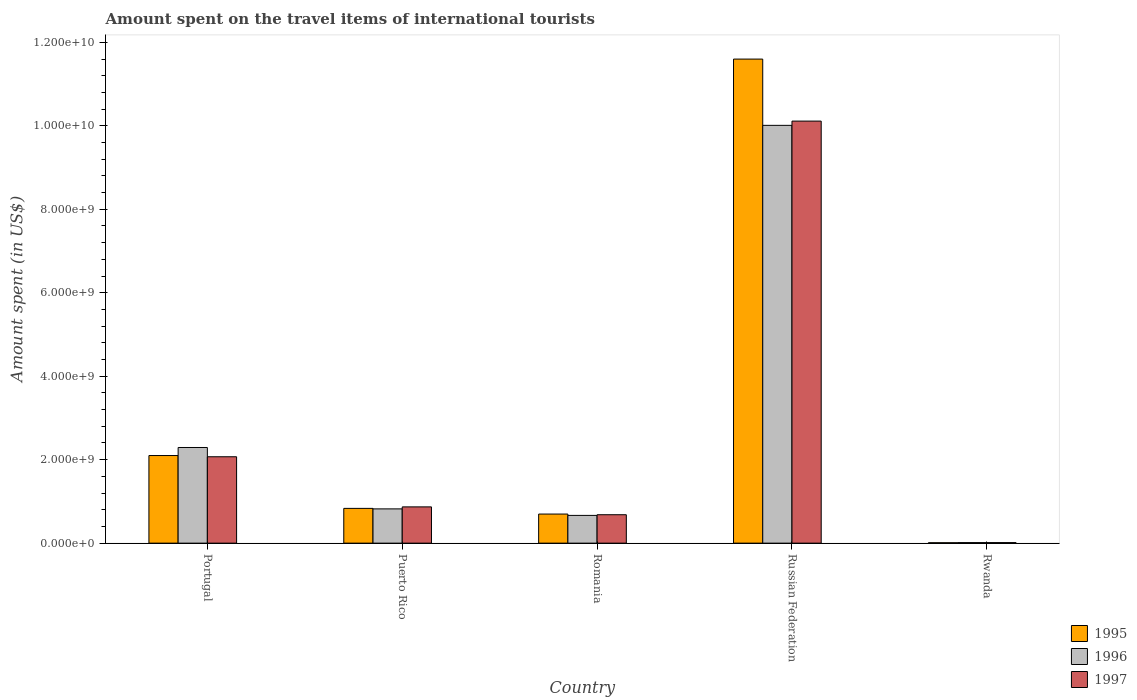How many different coloured bars are there?
Make the answer very short. 3. How many groups of bars are there?
Offer a very short reply. 5. Are the number of bars on each tick of the X-axis equal?
Give a very brief answer. Yes. How many bars are there on the 4th tick from the right?
Provide a succinct answer. 3. What is the label of the 4th group of bars from the left?
Provide a short and direct response. Russian Federation. What is the amount spent on the travel items of international tourists in 1996 in Romania?
Offer a very short reply. 6.65e+08. Across all countries, what is the maximum amount spent on the travel items of international tourists in 1995?
Your response must be concise. 1.16e+1. Across all countries, what is the minimum amount spent on the travel items of international tourists in 1997?
Your response must be concise. 1.30e+07. In which country was the amount spent on the travel items of international tourists in 1996 maximum?
Give a very brief answer. Russian Federation. In which country was the amount spent on the travel items of international tourists in 1996 minimum?
Give a very brief answer. Rwanda. What is the total amount spent on the travel items of international tourists in 1995 in the graph?
Provide a short and direct response. 1.52e+1. What is the difference between the amount spent on the travel items of international tourists in 1995 in Puerto Rico and that in Rwanda?
Ensure brevity in your answer.  8.23e+08. What is the difference between the amount spent on the travel items of international tourists in 1997 in Romania and the amount spent on the travel items of international tourists in 1995 in Puerto Rico?
Your answer should be very brief. -1.52e+08. What is the average amount spent on the travel items of international tourists in 1997 per country?
Your answer should be very brief. 2.75e+09. What is the difference between the amount spent on the travel items of international tourists of/in 1996 and amount spent on the travel items of international tourists of/in 1995 in Portugal?
Provide a short and direct response. 1.93e+08. In how many countries, is the amount spent on the travel items of international tourists in 1996 greater than 8000000000 US$?
Keep it short and to the point. 1. What is the ratio of the amount spent on the travel items of international tourists in 1996 in Puerto Rico to that in Rwanda?
Offer a very short reply. 63.15. Is the difference between the amount spent on the travel items of international tourists in 1996 in Puerto Rico and Romania greater than the difference between the amount spent on the travel items of international tourists in 1995 in Puerto Rico and Romania?
Your response must be concise. Yes. What is the difference between the highest and the second highest amount spent on the travel items of international tourists in 1995?
Provide a short and direct response. 1.08e+1. What is the difference between the highest and the lowest amount spent on the travel items of international tourists in 1996?
Offer a terse response. 1.00e+1. In how many countries, is the amount spent on the travel items of international tourists in 1996 greater than the average amount spent on the travel items of international tourists in 1996 taken over all countries?
Ensure brevity in your answer.  1. Is the sum of the amount spent on the travel items of international tourists in 1995 in Russian Federation and Rwanda greater than the maximum amount spent on the travel items of international tourists in 1996 across all countries?
Your response must be concise. Yes. What does the 2nd bar from the right in Russian Federation represents?
Your answer should be very brief. 1996. How many countries are there in the graph?
Give a very brief answer. 5. Are the values on the major ticks of Y-axis written in scientific E-notation?
Make the answer very short. Yes. Does the graph contain grids?
Give a very brief answer. No. What is the title of the graph?
Provide a succinct answer. Amount spent on the travel items of international tourists. Does "2004" appear as one of the legend labels in the graph?
Ensure brevity in your answer.  No. What is the label or title of the X-axis?
Give a very brief answer. Country. What is the label or title of the Y-axis?
Provide a succinct answer. Amount spent (in US$). What is the Amount spent (in US$) in 1995 in Portugal?
Ensure brevity in your answer.  2.10e+09. What is the Amount spent (in US$) in 1996 in Portugal?
Provide a short and direct response. 2.29e+09. What is the Amount spent (in US$) of 1997 in Portugal?
Keep it short and to the point. 2.07e+09. What is the Amount spent (in US$) of 1995 in Puerto Rico?
Provide a short and direct response. 8.33e+08. What is the Amount spent (in US$) of 1996 in Puerto Rico?
Make the answer very short. 8.21e+08. What is the Amount spent (in US$) in 1997 in Puerto Rico?
Keep it short and to the point. 8.69e+08. What is the Amount spent (in US$) in 1995 in Romania?
Offer a terse response. 6.97e+08. What is the Amount spent (in US$) in 1996 in Romania?
Your answer should be compact. 6.65e+08. What is the Amount spent (in US$) of 1997 in Romania?
Your answer should be compact. 6.81e+08. What is the Amount spent (in US$) in 1995 in Russian Federation?
Your answer should be compact. 1.16e+1. What is the Amount spent (in US$) in 1996 in Russian Federation?
Your answer should be compact. 1.00e+1. What is the Amount spent (in US$) of 1997 in Russian Federation?
Your answer should be very brief. 1.01e+1. What is the Amount spent (in US$) of 1995 in Rwanda?
Your answer should be very brief. 1.00e+07. What is the Amount spent (in US$) in 1996 in Rwanda?
Offer a terse response. 1.30e+07. What is the Amount spent (in US$) in 1997 in Rwanda?
Give a very brief answer. 1.30e+07. Across all countries, what is the maximum Amount spent (in US$) in 1995?
Offer a terse response. 1.16e+1. Across all countries, what is the maximum Amount spent (in US$) of 1996?
Your response must be concise. 1.00e+1. Across all countries, what is the maximum Amount spent (in US$) in 1997?
Provide a short and direct response. 1.01e+1. Across all countries, what is the minimum Amount spent (in US$) in 1995?
Give a very brief answer. 1.00e+07. Across all countries, what is the minimum Amount spent (in US$) of 1996?
Offer a very short reply. 1.30e+07. Across all countries, what is the minimum Amount spent (in US$) of 1997?
Provide a short and direct response. 1.30e+07. What is the total Amount spent (in US$) in 1995 in the graph?
Give a very brief answer. 1.52e+1. What is the total Amount spent (in US$) in 1996 in the graph?
Your answer should be very brief. 1.38e+1. What is the total Amount spent (in US$) of 1997 in the graph?
Keep it short and to the point. 1.37e+1. What is the difference between the Amount spent (in US$) in 1995 in Portugal and that in Puerto Rico?
Your answer should be very brief. 1.27e+09. What is the difference between the Amount spent (in US$) in 1996 in Portugal and that in Puerto Rico?
Ensure brevity in your answer.  1.47e+09. What is the difference between the Amount spent (in US$) of 1997 in Portugal and that in Puerto Rico?
Give a very brief answer. 1.20e+09. What is the difference between the Amount spent (in US$) of 1995 in Portugal and that in Romania?
Provide a succinct answer. 1.40e+09. What is the difference between the Amount spent (in US$) of 1996 in Portugal and that in Romania?
Make the answer very short. 1.63e+09. What is the difference between the Amount spent (in US$) of 1997 in Portugal and that in Romania?
Your answer should be very brief. 1.39e+09. What is the difference between the Amount spent (in US$) in 1995 in Portugal and that in Russian Federation?
Offer a terse response. -9.50e+09. What is the difference between the Amount spent (in US$) in 1996 in Portugal and that in Russian Federation?
Provide a succinct answer. -7.72e+09. What is the difference between the Amount spent (in US$) in 1997 in Portugal and that in Russian Federation?
Offer a terse response. -8.04e+09. What is the difference between the Amount spent (in US$) in 1995 in Portugal and that in Rwanda?
Your answer should be compact. 2.09e+09. What is the difference between the Amount spent (in US$) in 1996 in Portugal and that in Rwanda?
Keep it short and to the point. 2.28e+09. What is the difference between the Amount spent (in US$) of 1997 in Portugal and that in Rwanda?
Provide a succinct answer. 2.06e+09. What is the difference between the Amount spent (in US$) in 1995 in Puerto Rico and that in Romania?
Your answer should be compact. 1.36e+08. What is the difference between the Amount spent (in US$) of 1996 in Puerto Rico and that in Romania?
Offer a very short reply. 1.56e+08. What is the difference between the Amount spent (in US$) in 1997 in Puerto Rico and that in Romania?
Ensure brevity in your answer.  1.88e+08. What is the difference between the Amount spent (in US$) in 1995 in Puerto Rico and that in Russian Federation?
Make the answer very short. -1.08e+1. What is the difference between the Amount spent (in US$) of 1996 in Puerto Rico and that in Russian Federation?
Offer a terse response. -9.19e+09. What is the difference between the Amount spent (in US$) of 1997 in Puerto Rico and that in Russian Federation?
Your answer should be very brief. -9.24e+09. What is the difference between the Amount spent (in US$) in 1995 in Puerto Rico and that in Rwanda?
Your response must be concise. 8.23e+08. What is the difference between the Amount spent (in US$) of 1996 in Puerto Rico and that in Rwanda?
Provide a short and direct response. 8.08e+08. What is the difference between the Amount spent (in US$) in 1997 in Puerto Rico and that in Rwanda?
Make the answer very short. 8.56e+08. What is the difference between the Amount spent (in US$) of 1995 in Romania and that in Russian Federation?
Offer a terse response. -1.09e+1. What is the difference between the Amount spent (in US$) in 1996 in Romania and that in Russian Federation?
Ensure brevity in your answer.  -9.35e+09. What is the difference between the Amount spent (in US$) of 1997 in Romania and that in Russian Federation?
Offer a very short reply. -9.43e+09. What is the difference between the Amount spent (in US$) in 1995 in Romania and that in Rwanda?
Provide a short and direct response. 6.87e+08. What is the difference between the Amount spent (in US$) in 1996 in Romania and that in Rwanda?
Your answer should be compact. 6.52e+08. What is the difference between the Amount spent (in US$) of 1997 in Romania and that in Rwanda?
Your answer should be compact. 6.68e+08. What is the difference between the Amount spent (in US$) in 1995 in Russian Federation and that in Rwanda?
Your response must be concise. 1.16e+1. What is the difference between the Amount spent (in US$) of 1996 in Russian Federation and that in Rwanda?
Offer a terse response. 1.00e+1. What is the difference between the Amount spent (in US$) in 1997 in Russian Federation and that in Rwanda?
Offer a terse response. 1.01e+1. What is the difference between the Amount spent (in US$) of 1995 in Portugal and the Amount spent (in US$) of 1996 in Puerto Rico?
Ensure brevity in your answer.  1.28e+09. What is the difference between the Amount spent (in US$) in 1995 in Portugal and the Amount spent (in US$) in 1997 in Puerto Rico?
Your answer should be compact. 1.23e+09. What is the difference between the Amount spent (in US$) in 1996 in Portugal and the Amount spent (in US$) in 1997 in Puerto Rico?
Your response must be concise. 1.42e+09. What is the difference between the Amount spent (in US$) of 1995 in Portugal and the Amount spent (in US$) of 1996 in Romania?
Provide a succinct answer. 1.43e+09. What is the difference between the Amount spent (in US$) in 1995 in Portugal and the Amount spent (in US$) in 1997 in Romania?
Give a very brief answer. 1.42e+09. What is the difference between the Amount spent (in US$) of 1996 in Portugal and the Amount spent (in US$) of 1997 in Romania?
Your answer should be compact. 1.61e+09. What is the difference between the Amount spent (in US$) in 1995 in Portugal and the Amount spent (in US$) in 1996 in Russian Federation?
Keep it short and to the point. -7.91e+09. What is the difference between the Amount spent (in US$) of 1995 in Portugal and the Amount spent (in US$) of 1997 in Russian Federation?
Your answer should be very brief. -8.01e+09. What is the difference between the Amount spent (in US$) of 1996 in Portugal and the Amount spent (in US$) of 1997 in Russian Federation?
Give a very brief answer. -7.82e+09. What is the difference between the Amount spent (in US$) of 1995 in Portugal and the Amount spent (in US$) of 1996 in Rwanda?
Provide a short and direct response. 2.09e+09. What is the difference between the Amount spent (in US$) of 1995 in Portugal and the Amount spent (in US$) of 1997 in Rwanda?
Your response must be concise. 2.09e+09. What is the difference between the Amount spent (in US$) in 1996 in Portugal and the Amount spent (in US$) in 1997 in Rwanda?
Keep it short and to the point. 2.28e+09. What is the difference between the Amount spent (in US$) of 1995 in Puerto Rico and the Amount spent (in US$) of 1996 in Romania?
Offer a terse response. 1.68e+08. What is the difference between the Amount spent (in US$) of 1995 in Puerto Rico and the Amount spent (in US$) of 1997 in Romania?
Your answer should be very brief. 1.52e+08. What is the difference between the Amount spent (in US$) of 1996 in Puerto Rico and the Amount spent (in US$) of 1997 in Romania?
Offer a very short reply. 1.40e+08. What is the difference between the Amount spent (in US$) of 1995 in Puerto Rico and the Amount spent (in US$) of 1996 in Russian Federation?
Provide a short and direct response. -9.18e+09. What is the difference between the Amount spent (in US$) of 1995 in Puerto Rico and the Amount spent (in US$) of 1997 in Russian Federation?
Your answer should be very brief. -9.28e+09. What is the difference between the Amount spent (in US$) in 1996 in Puerto Rico and the Amount spent (in US$) in 1997 in Russian Federation?
Offer a terse response. -9.29e+09. What is the difference between the Amount spent (in US$) in 1995 in Puerto Rico and the Amount spent (in US$) in 1996 in Rwanda?
Keep it short and to the point. 8.20e+08. What is the difference between the Amount spent (in US$) of 1995 in Puerto Rico and the Amount spent (in US$) of 1997 in Rwanda?
Give a very brief answer. 8.20e+08. What is the difference between the Amount spent (in US$) in 1996 in Puerto Rico and the Amount spent (in US$) in 1997 in Rwanda?
Provide a succinct answer. 8.08e+08. What is the difference between the Amount spent (in US$) of 1995 in Romania and the Amount spent (in US$) of 1996 in Russian Federation?
Make the answer very short. -9.31e+09. What is the difference between the Amount spent (in US$) of 1995 in Romania and the Amount spent (in US$) of 1997 in Russian Federation?
Your answer should be compact. -9.42e+09. What is the difference between the Amount spent (in US$) in 1996 in Romania and the Amount spent (in US$) in 1997 in Russian Federation?
Your response must be concise. -9.45e+09. What is the difference between the Amount spent (in US$) of 1995 in Romania and the Amount spent (in US$) of 1996 in Rwanda?
Give a very brief answer. 6.84e+08. What is the difference between the Amount spent (in US$) in 1995 in Romania and the Amount spent (in US$) in 1997 in Rwanda?
Provide a short and direct response. 6.84e+08. What is the difference between the Amount spent (in US$) of 1996 in Romania and the Amount spent (in US$) of 1997 in Rwanda?
Your answer should be very brief. 6.52e+08. What is the difference between the Amount spent (in US$) in 1995 in Russian Federation and the Amount spent (in US$) in 1996 in Rwanda?
Ensure brevity in your answer.  1.16e+1. What is the difference between the Amount spent (in US$) of 1995 in Russian Federation and the Amount spent (in US$) of 1997 in Rwanda?
Keep it short and to the point. 1.16e+1. What is the difference between the Amount spent (in US$) in 1996 in Russian Federation and the Amount spent (in US$) in 1997 in Rwanda?
Make the answer very short. 1.00e+1. What is the average Amount spent (in US$) of 1995 per country?
Provide a short and direct response. 3.05e+09. What is the average Amount spent (in US$) of 1996 per country?
Ensure brevity in your answer.  2.76e+09. What is the average Amount spent (in US$) in 1997 per country?
Offer a terse response. 2.75e+09. What is the difference between the Amount spent (in US$) in 1995 and Amount spent (in US$) in 1996 in Portugal?
Ensure brevity in your answer.  -1.93e+08. What is the difference between the Amount spent (in US$) of 1995 and Amount spent (in US$) of 1997 in Portugal?
Provide a succinct answer. 2.90e+07. What is the difference between the Amount spent (in US$) of 1996 and Amount spent (in US$) of 1997 in Portugal?
Provide a short and direct response. 2.22e+08. What is the difference between the Amount spent (in US$) of 1995 and Amount spent (in US$) of 1996 in Puerto Rico?
Provide a succinct answer. 1.20e+07. What is the difference between the Amount spent (in US$) of 1995 and Amount spent (in US$) of 1997 in Puerto Rico?
Your answer should be compact. -3.60e+07. What is the difference between the Amount spent (in US$) in 1996 and Amount spent (in US$) in 1997 in Puerto Rico?
Provide a short and direct response. -4.80e+07. What is the difference between the Amount spent (in US$) of 1995 and Amount spent (in US$) of 1996 in Romania?
Provide a succinct answer. 3.20e+07. What is the difference between the Amount spent (in US$) in 1995 and Amount spent (in US$) in 1997 in Romania?
Ensure brevity in your answer.  1.60e+07. What is the difference between the Amount spent (in US$) of 1996 and Amount spent (in US$) of 1997 in Romania?
Offer a terse response. -1.60e+07. What is the difference between the Amount spent (in US$) in 1995 and Amount spent (in US$) in 1996 in Russian Federation?
Keep it short and to the point. 1.59e+09. What is the difference between the Amount spent (in US$) of 1995 and Amount spent (in US$) of 1997 in Russian Federation?
Provide a succinct answer. 1.49e+09. What is the difference between the Amount spent (in US$) in 1996 and Amount spent (in US$) in 1997 in Russian Federation?
Your response must be concise. -1.02e+08. What is the difference between the Amount spent (in US$) of 1995 and Amount spent (in US$) of 1997 in Rwanda?
Offer a terse response. -3.00e+06. What is the difference between the Amount spent (in US$) in 1996 and Amount spent (in US$) in 1997 in Rwanda?
Keep it short and to the point. 0. What is the ratio of the Amount spent (in US$) of 1995 in Portugal to that in Puerto Rico?
Offer a terse response. 2.52. What is the ratio of the Amount spent (in US$) of 1996 in Portugal to that in Puerto Rico?
Ensure brevity in your answer.  2.79. What is the ratio of the Amount spent (in US$) of 1997 in Portugal to that in Puerto Rico?
Make the answer very short. 2.38. What is the ratio of the Amount spent (in US$) of 1995 in Portugal to that in Romania?
Make the answer very short. 3.01. What is the ratio of the Amount spent (in US$) in 1996 in Portugal to that in Romania?
Provide a succinct answer. 3.45. What is the ratio of the Amount spent (in US$) of 1997 in Portugal to that in Romania?
Provide a short and direct response. 3.04. What is the ratio of the Amount spent (in US$) of 1995 in Portugal to that in Russian Federation?
Keep it short and to the point. 0.18. What is the ratio of the Amount spent (in US$) in 1996 in Portugal to that in Russian Federation?
Your response must be concise. 0.23. What is the ratio of the Amount spent (in US$) of 1997 in Portugal to that in Russian Federation?
Ensure brevity in your answer.  0.2. What is the ratio of the Amount spent (in US$) of 1995 in Portugal to that in Rwanda?
Ensure brevity in your answer.  209.9. What is the ratio of the Amount spent (in US$) of 1996 in Portugal to that in Rwanda?
Provide a short and direct response. 176.31. What is the ratio of the Amount spent (in US$) in 1997 in Portugal to that in Rwanda?
Provide a short and direct response. 159.23. What is the ratio of the Amount spent (in US$) in 1995 in Puerto Rico to that in Romania?
Your answer should be compact. 1.2. What is the ratio of the Amount spent (in US$) in 1996 in Puerto Rico to that in Romania?
Keep it short and to the point. 1.23. What is the ratio of the Amount spent (in US$) in 1997 in Puerto Rico to that in Romania?
Provide a short and direct response. 1.28. What is the ratio of the Amount spent (in US$) in 1995 in Puerto Rico to that in Russian Federation?
Offer a very short reply. 0.07. What is the ratio of the Amount spent (in US$) of 1996 in Puerto Rico to that in Russian Federation?
Give a very brief answer. 0.08. What is the ratio of the Amount spent (in US$) in 1997 in Puerto Rico to that in Russian Federation?
Your answer should be compact. 0.09. What is the ratio of the Amount spent (in US$) of 1995 in Puerto Rico to that in Rwanda?
Your response must be concise. 83.3. What is the ratio of the Amount spent (in US$) in 1996 in Puerto Rico to that in Rwanda?
Your response must be concise. 63.15. What is the ratio of the Amount spent (in US$) in 1997 in Puerto Rico to that in Rwanda?
Provide a succinct answer. 66.85. What is the ratio of the Amount spent (in US$) of 1995 in Romania to that in Russian Federation?
Provide a succinct answer. 0.06. What is the ratio of the Amount spent (in US$) in 1996 in Romania to that in Russian Federation?
Your answer should be compact. 0.07. What is the ratio of the Amount spent (in US$) in 1997 in Romania to that in Russian Federation?
Give a very brief answer. 0.07. What is the ratio of the Amount spent (in US$) in 1995 in Romania to that in Rwanda?
Offer a terse response. 69.7. What is the ratio of the Amount spent (in US$) in 1996 in Romania to that in Rwanda?
Offer a terse response. 51.15. What is the ratio of the Amount spent (in US$) in 1997 in Romania to that in Rwanda?
Ensure brevity in your answer.  52.38. What is the ratio of the Amount spent (in US$) in 1995 in Russian Federation to that in Rwanda?
Ensure brevity in your answer.  1159.9. What is the ratio of the Amount spent (in US$) of 1996 in Russian Federation to that in Rwanda?
Provide a succinct answer. 770.08. What is the ratio of the Amount spent (in US$) of 1997 in Russian Federation to that in Rwanda?
Your answer should be very brief. 777.92. What is the difference between the highest and the second highest Amount spent (in US$) in 1995?
Offer a very short reply. 9.50e+09. What is the difference between the highest and the second highest Amount spent (in US$) in 1996?
Provide a short and direct response. 7.72e+09. What is the difference between the highest and the second highest Amount spent (in US$) of 1997?
Your answer should be very brief. 8.04e+09. What is the difference between the highest and the lowest Amount spent (in US$) of 1995?
Ensure brevity in your answer.  1.16e+1. What is the difference between the highest and the lowest Amount spent (in US$) in 1996?
Keep it short and to the point. 1.00e+1. What is the difference between the highest and the lowest Amount spent (in US$) in 1997?
Offer a terse response. 1.01e+1. 